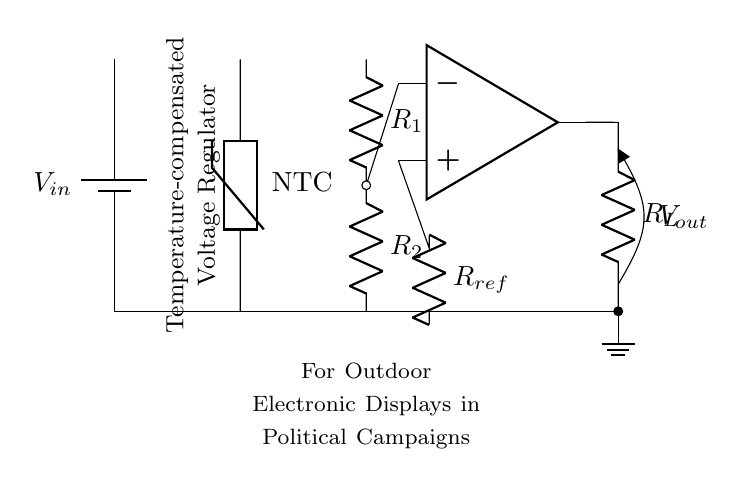What is the type of sensor used in this circuit? The circuit diagram shows an NTC thermistor, which is commonly used for temperature sensing as it decreases resistance with an increase in temperature.
Answer: NTC thermistor What is the purpose of the op-amp in this circuit? The operational amplifier is used to amplify the voltage difference between the inverting and non-inverting inputs, helping to regulate the output voltage based on temperature changes detected by the thermistor.
Answer: Regulation What are the values of the resistors in the voltage divider? The circuit specifies the presence of resistors R1 and R2, but does not provide numerical values; they are essential for establishing the output voltage based on the thermistor's resistance.
Answer: R1 and R2 What component is responsible for temperature compensation in this design? The NTC thermistor is responsible for temperature compensation by adjusting the voltage according to temperature variations, which is essential for maintaining a stable output voltage despite changing conditions.
Answer: NTC thermistor What is the output voltage indicated in the diagram? The circuit specifies Vo as the output voltage, linking the operational amplifier's output to a load resistor, but does not denote a specific value, highlighting that the output will vary based on the thermistor’s reading.
Answer: Vout 